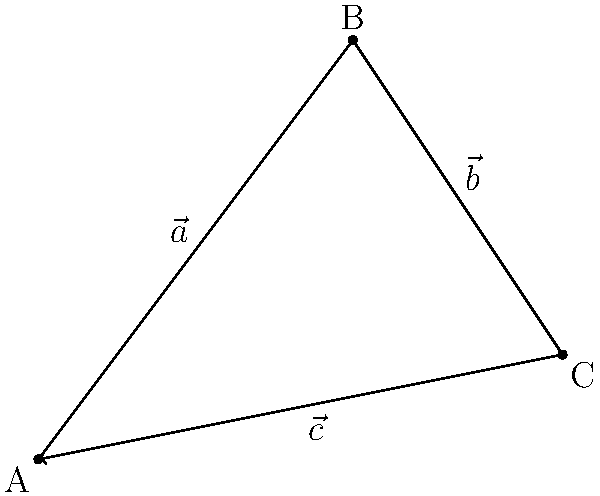In a complex divorce case, you're representing the husband in asset distribution negotiations. The court has determined that the total marital assets can be represented by vector $\vec{c}$. Your client's individual assets are represented by vector $\vec{a}$, while his wife's assets are represented by vector $\vec{b}$. Given that $\vec{a} = 3\hat{i} + 4\hat{j}$ and $\vec{b} = 2\hat{i} - 3\hat{j}$, what is the magnitude of the total marital assets $\vec{c}$? To solve this problem, we need to follow these steps:

1) First, we know that the total marital assets $\vec{c}$ is the sum of the husband's assets $\vec{a}$ and the wife's assets $\vec{b}$:

   $\vec{c} = \vec{a} + \vec{b}$

2) We're given the components of $\vec{a}$ and $\vec{b}$:
   
   $\vec{a} = 3\hat{i} + 4\hat{j}$
   $\vec{b} = 2\hat{i} - 3\hat{j}$

3) Let's add these vectors component-wise:

   $\vec{c} = (3\hat{i} + 4\hat{j}) + (2\hat{i} - 3\hat{j})$
   $\vec{c} = (3 + 2)\hat{i} + (4 - 3)\hat{j}$
   $\vec{c} = 5\hat{i} + 1\hat{j}$

4) Now that we have $\vec{c}$ in component form, we can find its magnitude using the Pythagorean theorem:

   $|\vec{c}| = \sqrt{5^2 + 1^2}$

5) Simplify:

   $|\vec{c}| = \sqrt{25 + 1} = \sqrt{26}$

Therefore, the magnitude of the total marital assets is $\sqrt{26}$ units.
Answer: $\sqrt{26}$ units 